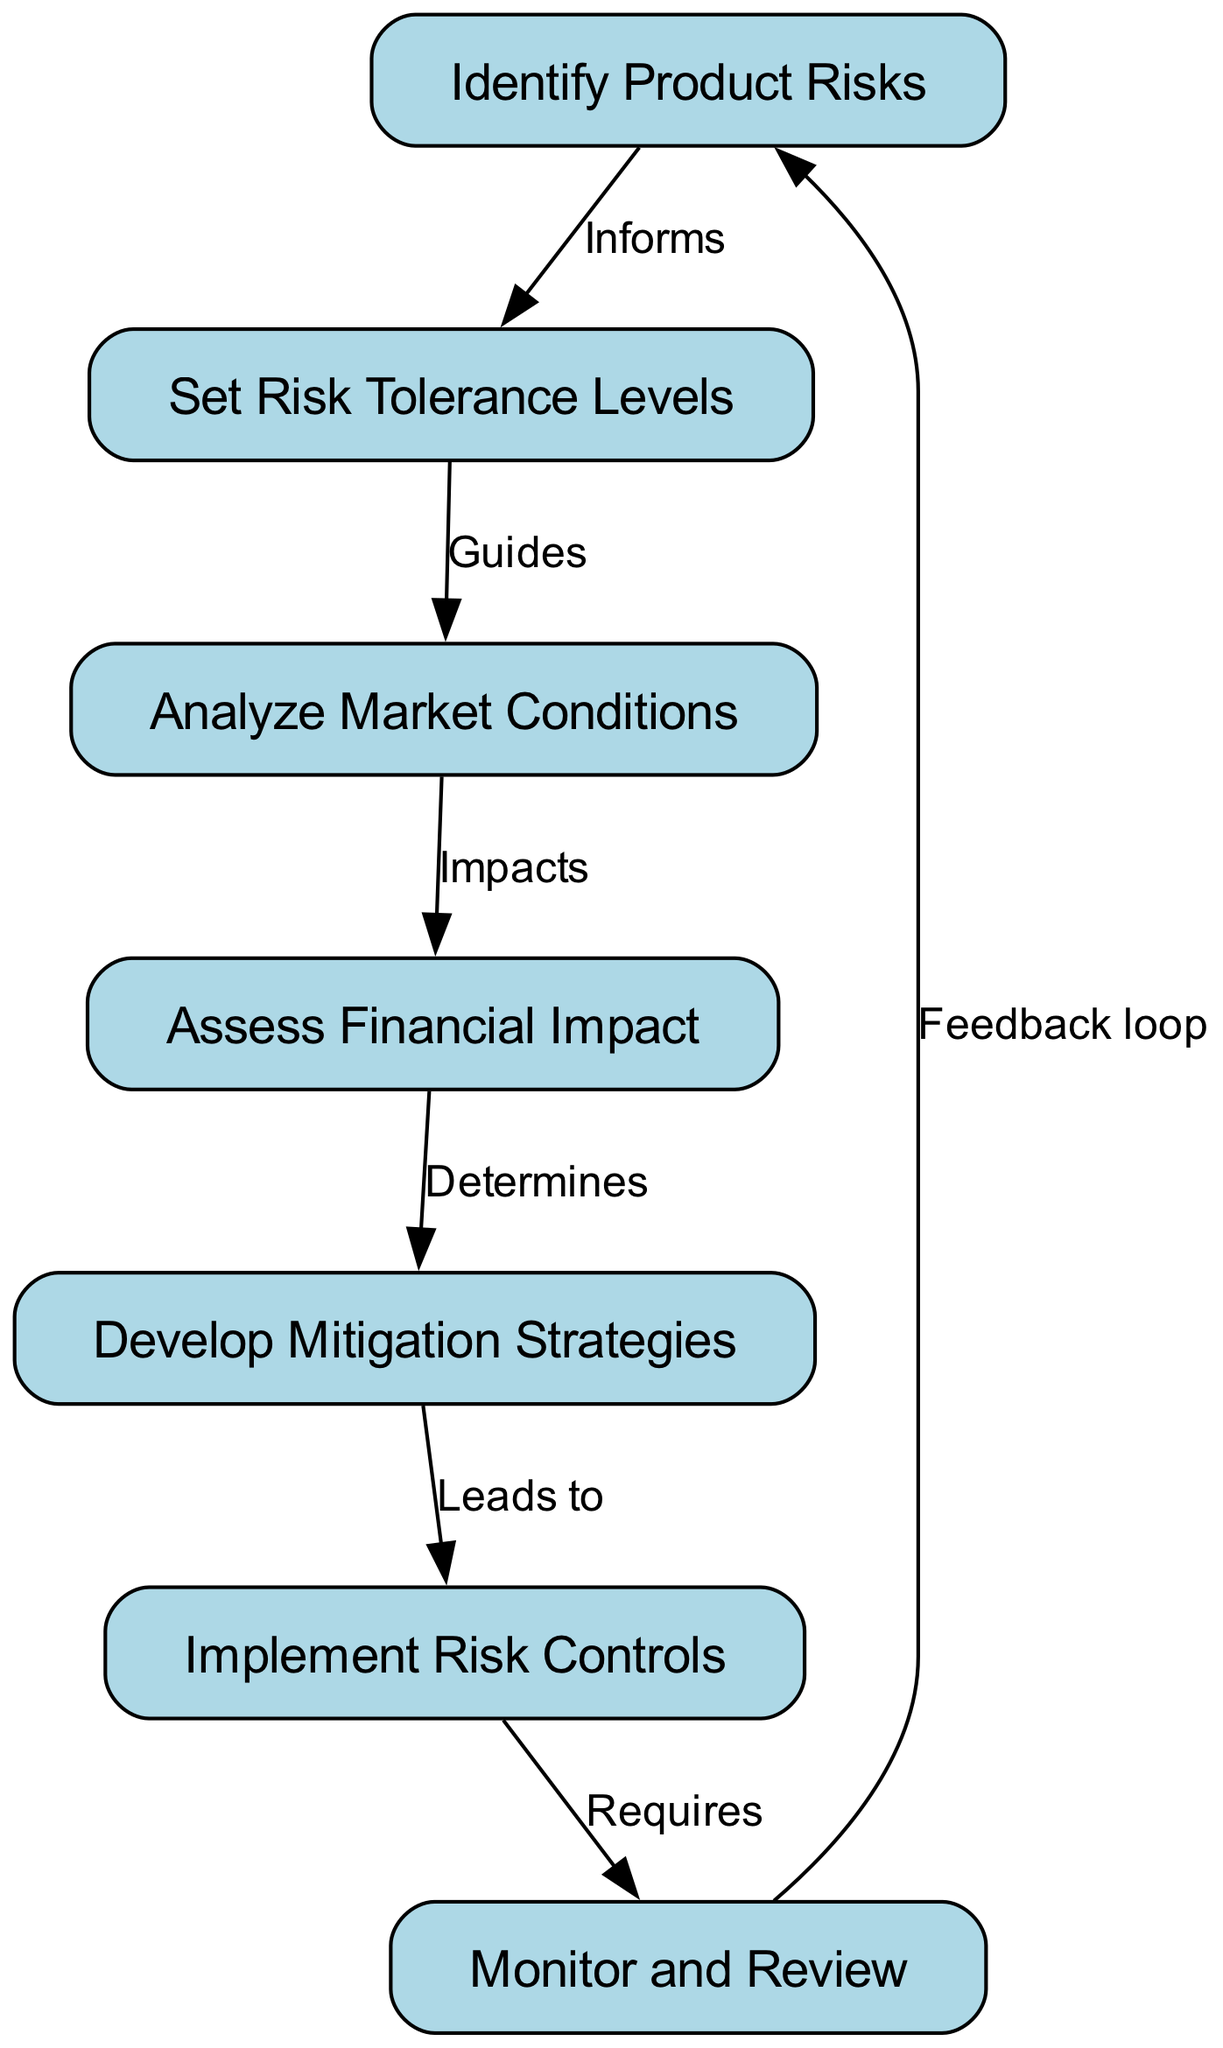What is the first step in the risk assessment process? The flowchart begins with the node labeled "Identify Product Risks," indicating it is the initial step in the process.
Answer: Identify Product Risks How many nodes are present in the diagram? By counting all the distinct labeled steps in the flowchart, there are seven nodes in total.
Answer: 7 What does the "Set Risk Tolerance Levels" node inform? According to the diagram, "Set Risk Tolerance Levels" is informed by the previous step, which is "Identify Product Risks."
Answer: Identify Product Risks Which node is directly impacted by "Analyze Market Conditions"? The diagram shows that "Assess Financial Impact" is impacted by the node "Analyze Market Conditions," as indicated by the directional edge between them.
Answer: Assess Financial Impact What leads to the implementation of risk controls? The flowchart indicates that the development of "Mitigation Strategies" leads to the "Implement Risk Controls" step, establishing a clear sequence in the process.
Answer: Develop Mitigation Strategies Which two nodes create a feedback loop? The feedback loop in the diagram is established between the "Monitor and Review" and "Identify Product Risks" nodes, indicating that monitoring influences future risk identification.
Answer: Monitor and Review, Identify Product Risks What type of relationship exists between "Assess Financial Impact" and "Develop Mitigation Strategies"? The relationship is defined as a determining factor, where "Assess Financial Impact" determines the strategies developed for mitigation.
Answer: Determines What is the final step in the risk assessment and mitigation process? According to the flowchart, the last action taken in the process is "Monitor and Review," indicating it concludes the cycle of risk management.
Answer: Monitor and Review 